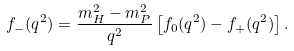<formula> <loc_0><loc_0><loc_500><loc_500>f _ { - } ( q ^ { 2 } ) = \frac { m _ { H } ^ { 2 } - m _ { P } ^ { 2 } } { q ^ { 2 } } \left [ f _ { 0 } ( q ^ { 2 } ) - f _ { + } ( q ^ { 2 } ) \right ] .</formula> 